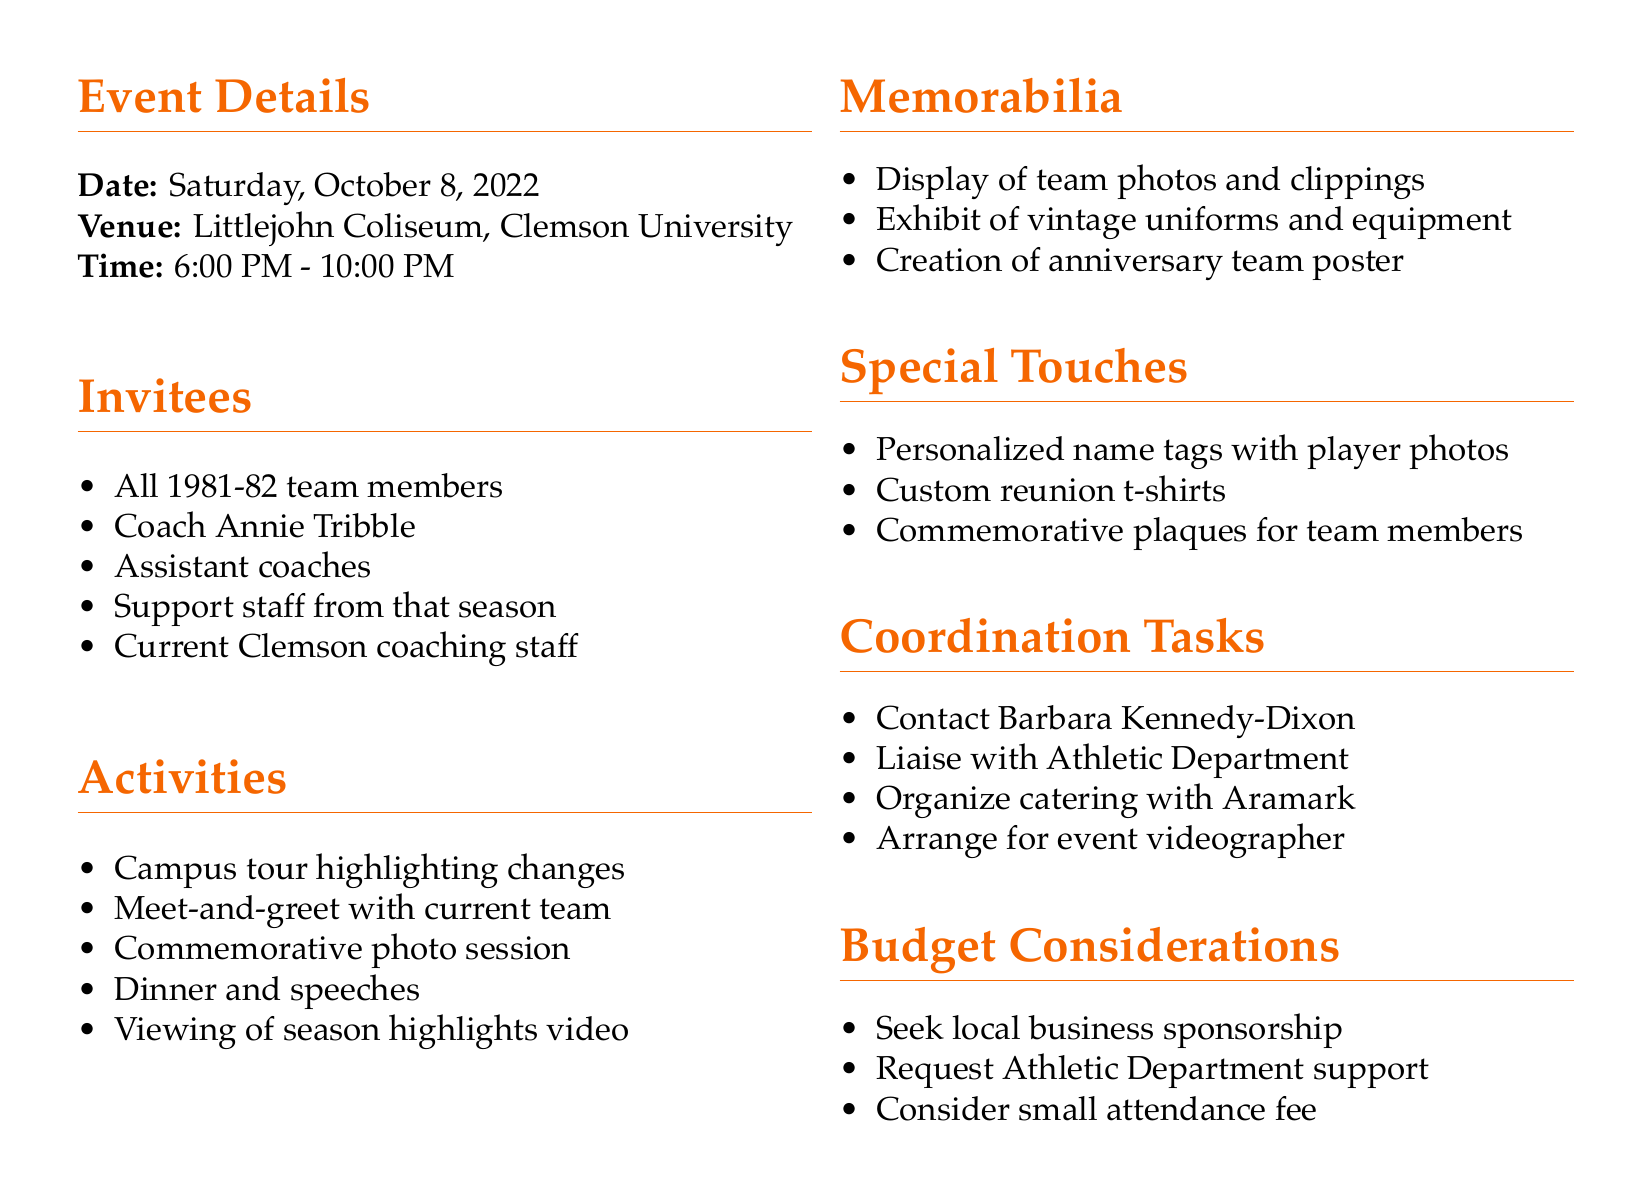What is the date of the reunion? The date of the reunion is listed in the document under event details.
Answer: Saturday, October 8, 2022 Where will the reunion take place? The venue for the reunion is specified in the event details section.
Answer: Littlejohn Coliseum, Clemson University What time does the event start? The starting time for the event is included in the event details.
Answer: 6:00 PM Who is responsible for coordinating the event? The document specifies a person to contact for assistance in reaching out to former teammates.
Answer: Barbara Kennedy-Dixon What type of memorabilia will be displayed? There is a section detailing memorabilia that will be showcased during the reunion.
Answer: Team photos and newspaper clippings How long is the reunion scheduled to last? The time range for the event is mentioned in the document.
Answer: 4 hours What is one of the planned activities during the reunion? The activities section lists various activities scheduled for the reunion.
Answer: Commemorative photo session What will be provided to attendees as a special touch? The special touches section outlines unique items for attendees.
Answer: Personalized name tags What organization will the caterer for the event be affiliated with? The coordination tasks mention the food service provider for catering.
Answer: Aramark 